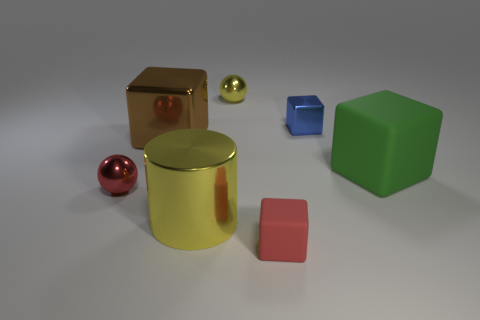Subtract all purple spheres. Subtract all cyan cubes. How many spheres are left? 2 Add 1 small cyan shiny objects. How many objects exist? 8 Subtract all balls. How many objects are left? 5 Subtract 0 blue spheres. How many objects are left? 7 Subtract all yellow shiny objects. Subtract all blue things. How many objects are left? 4 Add 3 brown blocks. How many brown blocks are left? 4 Add 4 blue things. How many blue things exist? 5 